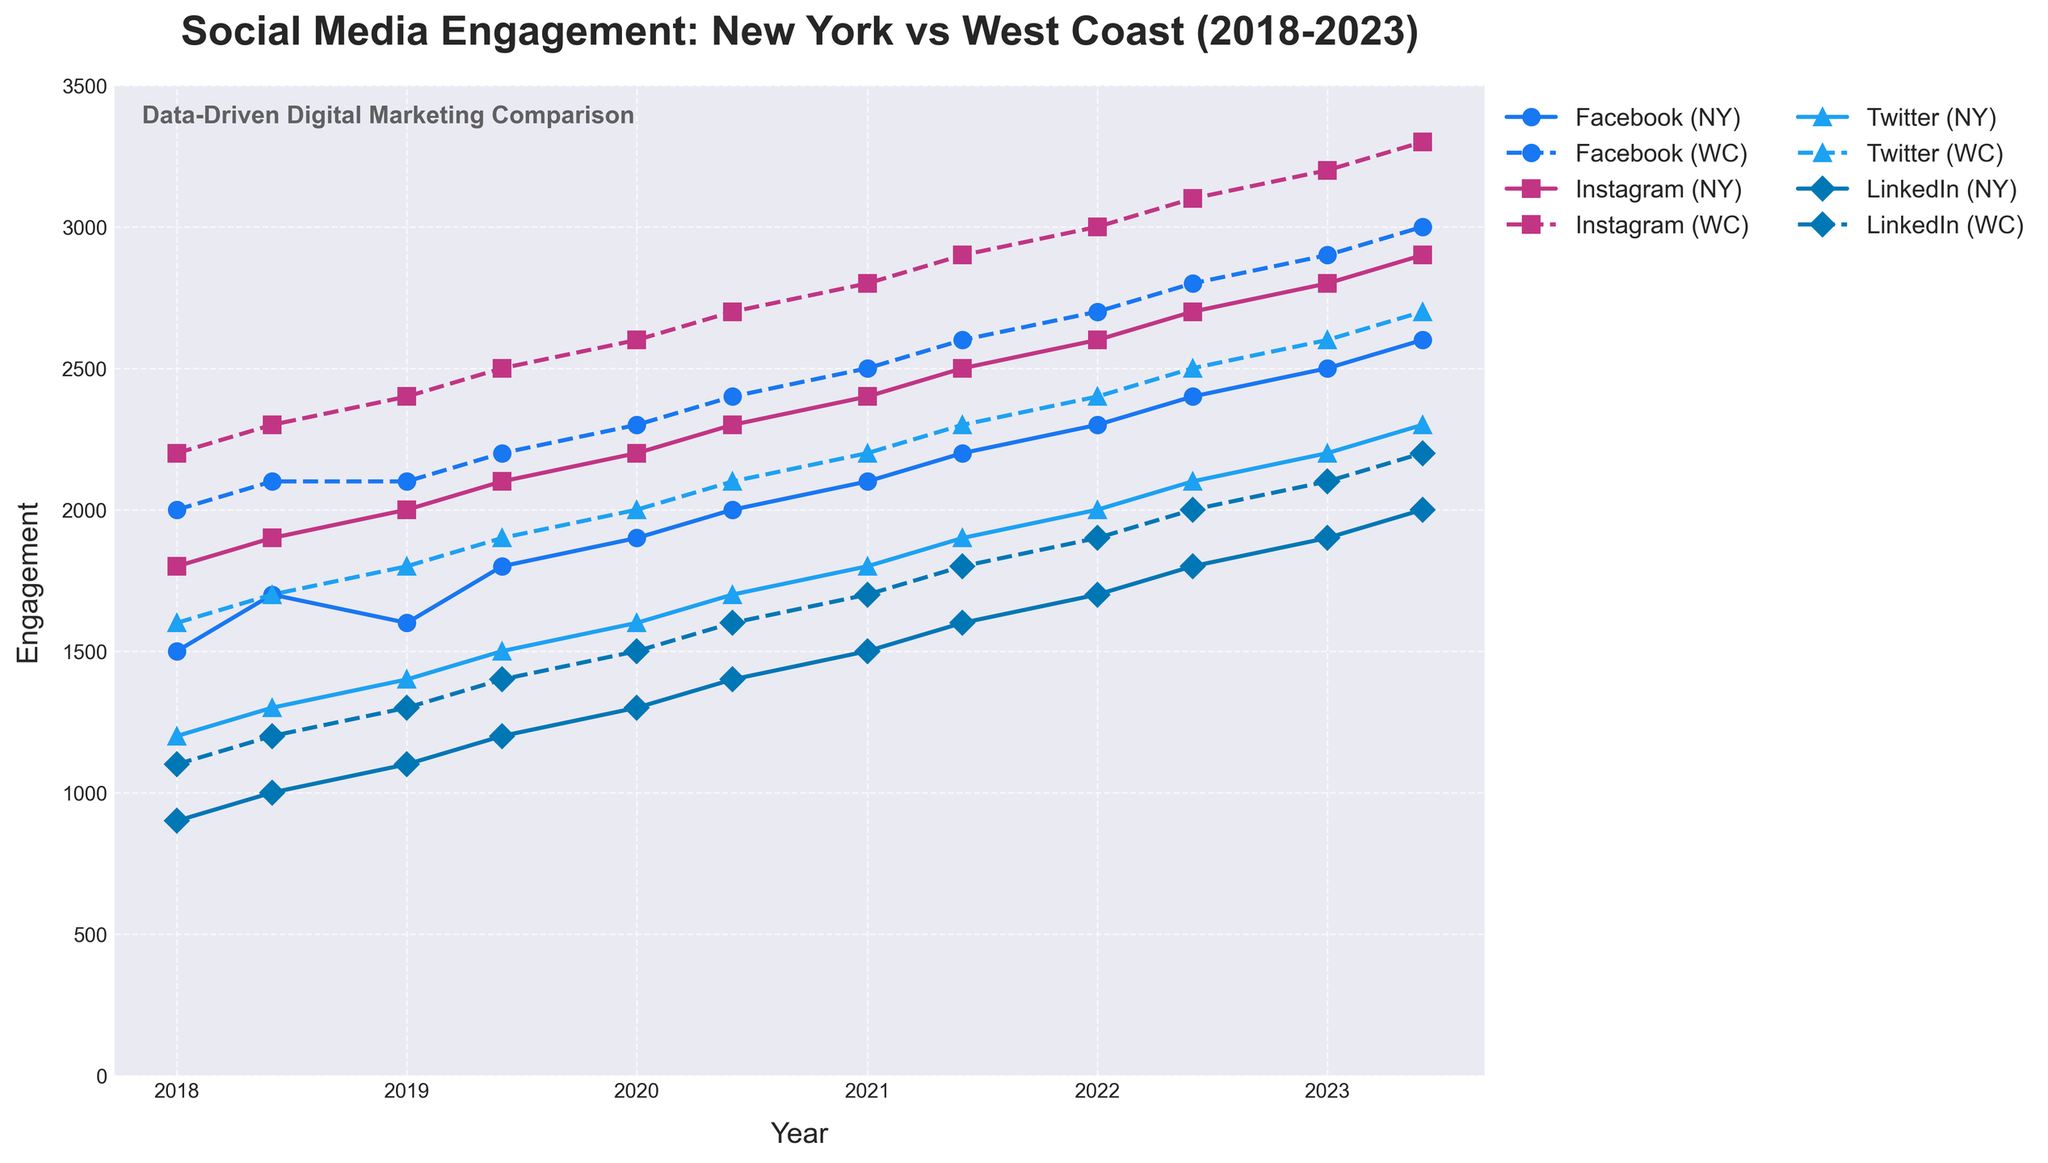What is the title of the plot? The title is prominently displayed at the top of the figure and typically describes the purpose of the plot.
Answer: Social Media Engagement: New York vs West Coast (2018-2023) How are the lines styled for New York and West Coast engagements for Facebook? By observing the line styles in the legend or in the plot, you can identify that New York engagement lines are solid and West Coast lines are dashed.
Answer: New York lines are solid, West Coast lines are dashed Which platform has the highest engagement in New York in January 2023? Look at January 2023 data points for New York engagements across all platforms and identify the one with the highest value.
Answer: Instagram Which region had higher LinkedIn engagement in June 2020, and by how much? By comparing the New York and West Coast engagement values for LinkedIn in June 2020 directly on the plot, you can determine the difference.
Answer: West Coast by 200 Which platform shows the largest overall increase in engagement in both regions from 2018 to 2023? Track each platform's engagement from 2018 to 2023 in both regions and identify the one with the largest increase.
Answer: Instagram What trend do you observe in Instagram engagement for both regions over the last five years? Observe the plot lines for Instagram from 2018 to 2023 and describe the direction and pattern of the trend.
Answer: Increasing trend in both regions What is the general difference in Twitter engagement between New York and the West Coast over the five years? Compare the engagement lines for Twitter across multiple time points to determine the overall difference.
Answer: West Coast generally higher How does the LinkedIn engagement in New York in June 2018 compare to January 2022? Identify the data points for LinkedIn engagement in New York for June 2018 and January 2022 and compare their values.
Answer: January 2022 is higher by 800 Which month and year had the lowest engagement for Facebook in New York? Find the data points for Facebook's New York engagement across all months and years and identify the lowest value.
Answer: January 2018 